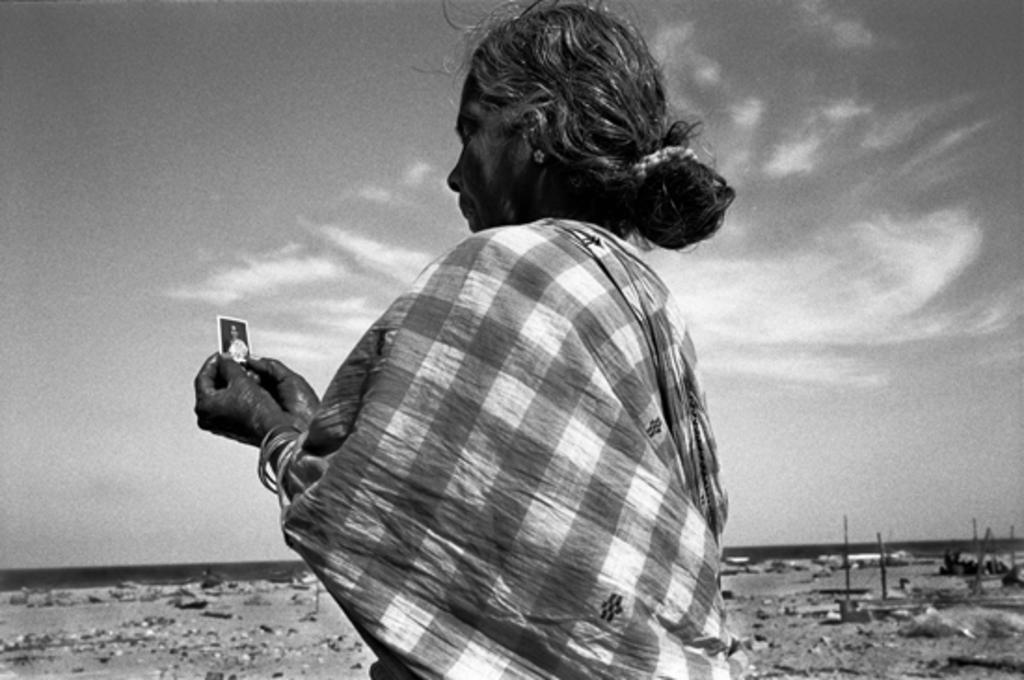What is the color scheme of the image? The image is black and white. Can you describe the main subject in the image? There is a lady in the image. What is the lady wearing? The lady is wearing something, but the specific clothing cannot be determined from the black and white image. What can be seen in the background of the image? There is sky visible in the background of the image, and there are clouds present. What type of protest is the lady participating in, as seen in the image? There is no protest visible in the image; it only features a lady in a black and white setting with a sky and clouds in the background. 